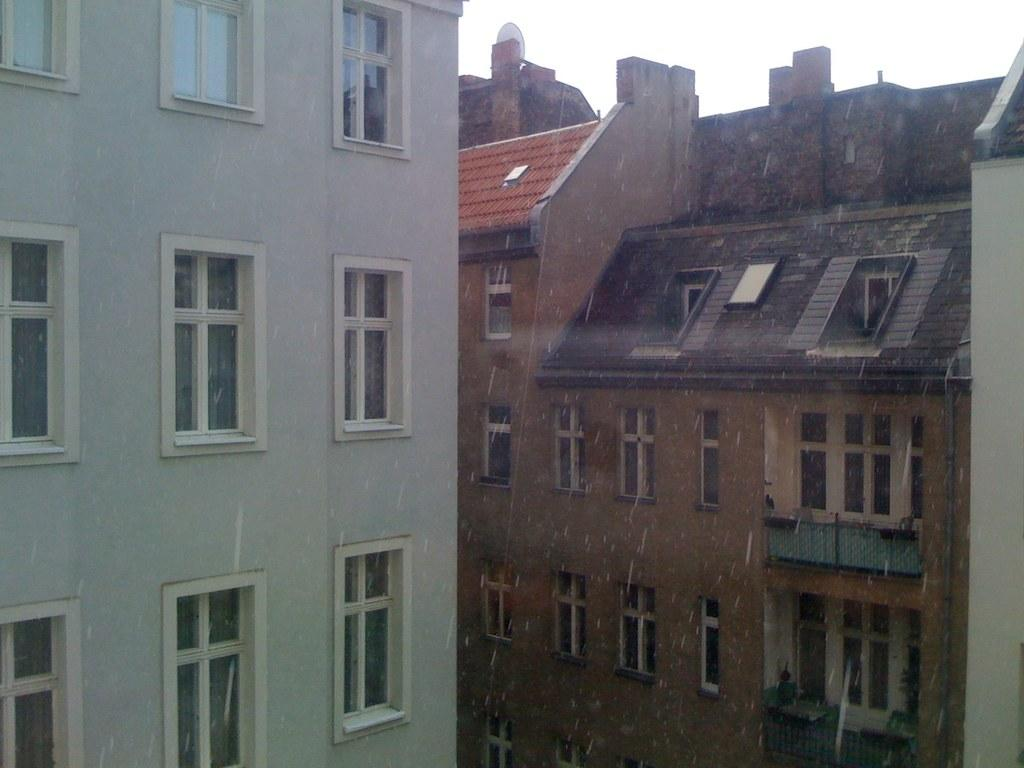What type of structures can be seen in the image? There are buildings in the image. Can you describe any specific features of the buildings? Multiple windows are visible in the image. What color is the girl's hair in the image? There is no girl present in the image, so we cannot determine the color of her hair. 